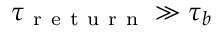Convert formula to latex. <formula><loc_0><loc_0><loc_500><loc_500>\tau _ { r e t u r n } \gg \tau _ { b }</formula> 